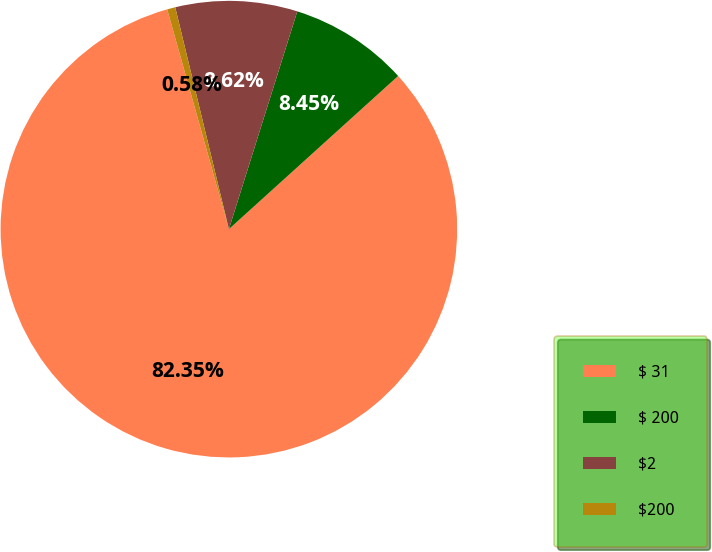Convert chart to OTSL. <chart><loc_0><loc_0><loc_500><loc_500><pie_chart><fcel>$ 31<fcel>$ 200<fcel>$2<fcel>$200<nl><fcel>82.35%<fcel>8.45%<fcel>8.62%<fcel>0.58%<nl></chart> 